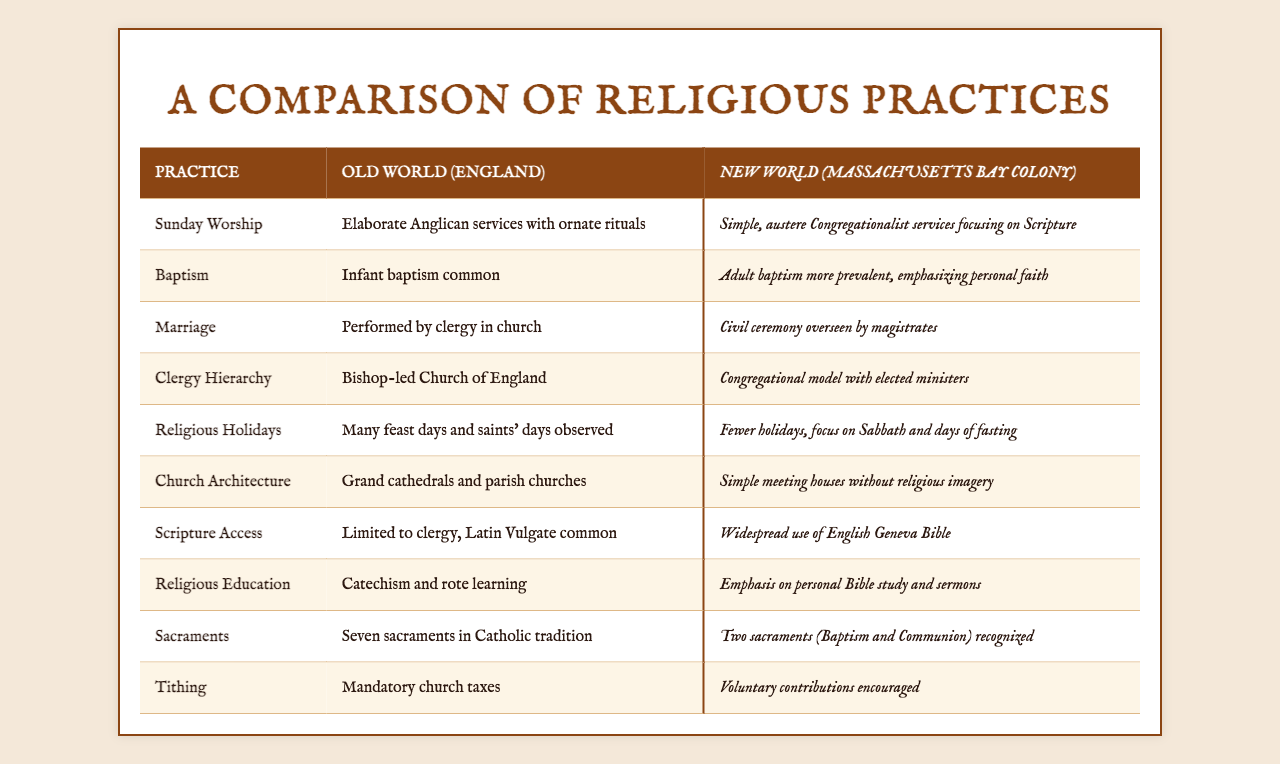What type of baptism is more common in the New World? The table indicates that adult baptism is more prevalent in the New World, focusing on personal faith, while infant baptism is common in the Old World.
Answer: Adult baptism How many sacraments are recognized in the New World? According to the table, the New World recognizes two sacraments: Baptism and Communion, whereas the Old World recognizes seven.
Answer: Two Is the church architecture in the Old World more elaborate than in the New World? The table shows that the Old World has grand cathedrals and parish churches, while the New World has simple meeting houses without religious imagery, indicating that it is indeed more elaborate in the Old World.
Answer: Yes Which region emphasizes personal Bible study more, the Old World or the New World? The New World places a higher emphasis on personal Bible study and sermons, while the Old World emphasizes catechism and rote learning.
Answer: New World What is the difference in clergy hierarchy between the Old World and the New World? The Old World is led by a bishop-led Church of England, whereas the New World adopts a congregational model with elected ministers, highlighting a significant difference in clergy hierarchy.
Answer: Different Are religious holidays more commonly observed in the Old World compared to the New World? The table states that the Old World observes many feast days and saints' days, while the New World focuses on fewer holidays and emphasizes the Sabbath and days of fasting, indicating a difference in the observance of religious holidays.
Answer: Yes What is the main focus of religious education in the New World? The New World emphasizes personal Bible study and sermons in religious education, contrasting with the Old World's focus on catechism and rote learning.
Answer: Personal Bible study How does the approach to tithing differ between the two worlds? The Old World has mandatory church taxes, while the New World encourages voluntary contributions, showing a contrast in how tithing is approached.
Answer: Voluntary contributions in New World What architectural style is favored in Old World churches compared to those in the New World? The architecture in the Old World is characterized by grand cathedrals and ornate structures, whereas the New World prefers simple meeting houses, showcasing a preference for simplicity.
Answer: Grand cathedrals If both regions perform the marriage ceremony, how do their practices differ? In the Old World, marriages are performed by clergy in church, while in the New World, they are civil ceremonies overseen by magistrates, indicating differing practices.
Answer: Different practices 